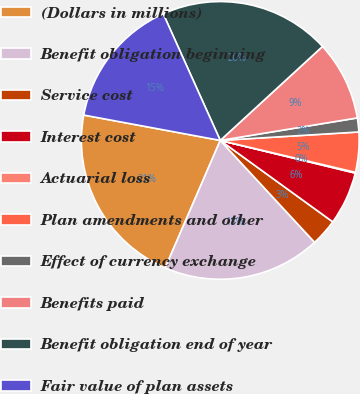Convert chart. <chart><loc_0><loc_0><loc_500><loc_500><pie_chart><fcel>(Dollars in millions)<fcel>Benefit obligation beginning<fcel>Service cost<fcel>Interest cost<fcel>Actuarial loss<fcel>Plan amendments and other<fcel>Effect of currency exchange<fcel>Benefits paid<fcel>Benefit obligation end of year<fcel>Fair value of plan assets<nl><fcel>21.43%<fcel>18.38%<fcel>3.14%<fcel>6.19%<fcel>0.09%<fcel>4.66%<fcel>1.62%<fcel>9.24%<fcel>19.91%<fcel>15.34%<nl></chart> 